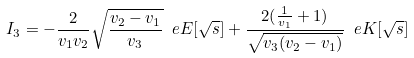Convert formula to latex. <formula><loc_0><loc_0><loc_500><loc_500>I _ { 3 } = - \frac { 2 } { v _ { 1 } v _ { 2 } } \sqrt { \frac { v _ { 2 } - v _ { 1 } } { v _ { 3 } } } \ e E [ \sqrt { s } ] + \frac { 2 ( \frac { 1 } { v _ { 1 } } + 1 ) } { \sqrt { v _ { 3 } ( v _ { 2 } - v _ { 1 } ) } } \ e K [ \sqrt { s } ]</formula> 